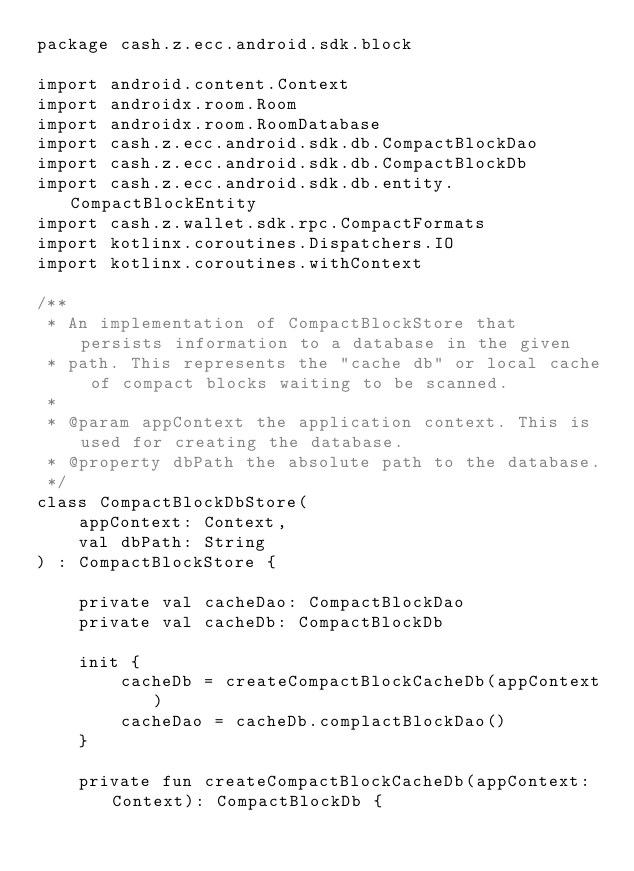Convert code to text. <code><loc_0><loc_0><loc_500><loc_500><_Kotlin_>package cash.z.ecc.android.sdk.block

import android.content.Context
import androidx.room.Room
import androidx.room.RoomDatabase
import cash.z.ecc.android.sdk.db.CompactBlockDao
import cash.z.ecc.android.sdk.db.CompactBlockDb
import cash.z.ecc.android.sdk.db.entity.CompactBlockEntity
import cash.z.wallet.sdk.rpc.CompactFormats
import kotlinx.coroutines.Dispatchers.IO
import kotlinx.coroutines.withContext

/**
 * An implementation of CompactBlockStore that persists information to a database in the given
 * path. This represents the "cache db" or local cache of compact blocks waiting to be scanned.
 *
 * @param appContext the application context. This is used for creating the database.
 * @property dbPath the absolute path to the database.
 */
class CompactBlockDbStore(
    appContext: Context,
    val dbPath: String
) : CompactBlockStore {

    private val cacheDao: CompactBlockDao
    private val cacheDb: CompactBlockDb

    init {
        cacheDb = createCompactBlockCacheDb(appContext)
        cacheDao = cacheDb.complactBlockDao()
    }

    private fun createCompactBlockCacheDb(appContext: Context): CompactBlockDb {</code> 